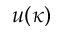Convert formula to latex. <formula><loc_0><loc_0><loc_500><loc_500>u ( \kappa )</formula> 